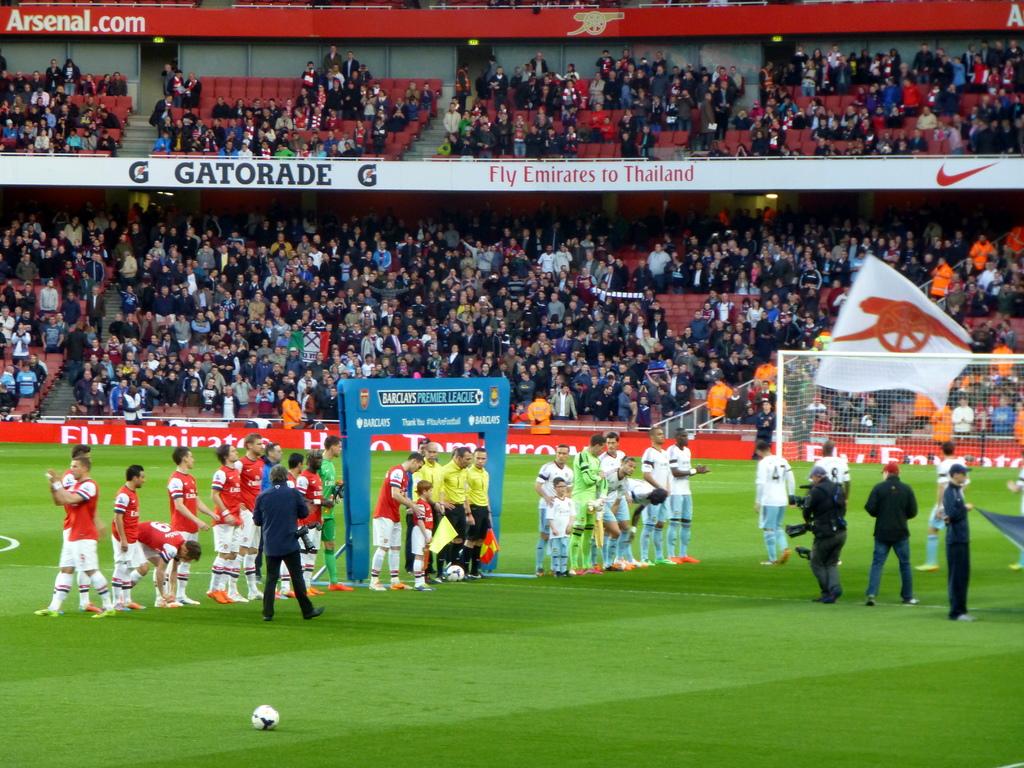What drink is on the banner in the background?
Your answer should be very brief. Gatorade. 